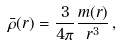Convert formula to latex. <formula><loc_0><loc_0><loc_500><loc_500>\bar { \rho } ( r ) = \frac { 3 } { 4 \pi } \frac { m ( r ) } { r ^ { 3 } } \, ,</formula> 